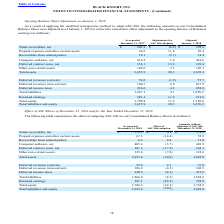According to Black Knight Financial Services's financial document, What were the Receivables from related parties as reported in 2018? According to the financial document, 6.2 (in millions). The relevant text states: "Receivables from related parties 6.2 4.8 11.0..." Also, What was the effect of ASC 606 adoption on net computer software? According to the financial document, (3.7) (in millions). The relevant text states: "Computer software, net 405.6 (3.7) 401.9..." Also, What were the total assets without the adoption of ASC 606? According to the financial document, 3,622.8 (in millions). The relevant text states: "Total assets 3,653.4 (30.6) 3,622.8..." Also, can you calculate: What was the difference the effect of ASC 606 Adoption between Total Assets and Total Liabilities? Based on the calculation: -8.3-(-30.6), the result is 22.3 (in millions). This is based on the information: "Total liabilities 1,866.9 (8.3) 1,858.6 Total assets 3,653.4 (30.6) 3,622.8..." The key data points involved are: 30.6, 8.3. Also, can you calculate: What was total equity as a percentage of total liabilities and equity as reported in 2018? Based on the calculation: 1,786.5/3,653.4, the result is 48.9 (percentage). This is based on the information: "Total equity 1,786.5 (22.3) 1,764.2 Total assets 3,653.4 (30.6) 3,622.8..." The key data points involved are: 1,786.5, 3,653.4. Also, can you calculate: What was the difference in the reported amount in 2018 between net computer software and net deferred contract costs? Based on the calculation: 405.6-161.3, the result is 244.3 (in millions). This is based on the information: "Computer software, net 405.6 (3.7) 401.9 Deferred contract costs, net 161.3 (17.2) 144.1..." The key data points involved are: 161.3, 405.6. 